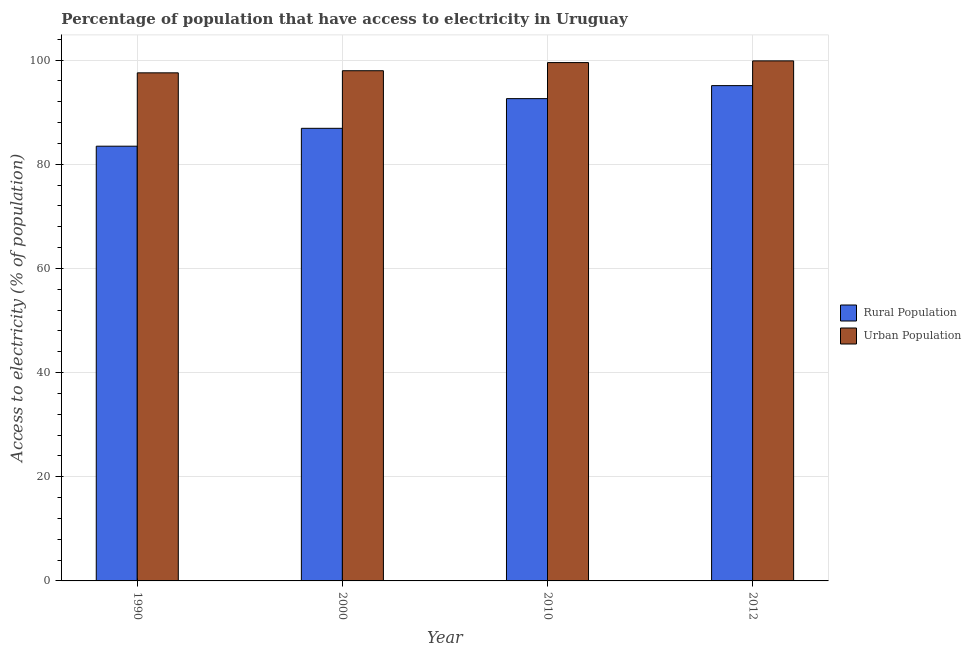Are the number of bars per tick equal to the number of legend labels?
Offer a terse response. Yes. Are the number of bars on each tick of the X-axis equal?
Give a very brief answer. Yes. What is the percentage of rural population having access to electricity in 2000?
Give a very brief answer. 86.9. Across all years, what is the maximum percentage of rural population having access to electricity?
Ensure brevity in your answer.  95.1. Across all years, what is the minimum percentage of rural population having access to electricity?
Offer a terse response. 83.47. In which year was the percentage of urban population having access to electricity maximum?
Provide a short and direct response. 2012. What is the total percentage of urban population having access to electricity in the graph?
Ensure brevity in your answer.  394.88. What is the difference between the percentage of urban population having access to electricity in 2010 and that in 2012?
Offer a terse response. -0.33. What is the difference between the percentage of urban population having access to electricity in 2012 and the percentage of rural population having access to electricity in 2010?
Ensure brevity in your answer.  0.33. What is the average percentage of urban population having access to electricity per year?
Your answer should be compact. 98.72. What is the ratio of the percentage of rural population having access to electricity in 2000 to that in 2010?
Offer a terse response. 0.94. Is the difference between the percentage of urban population having access to electricity in 2000 and 2010 greater than the difference between the percentage of rural population having access to electricity in 2000 and 2010?
Give a very brief answer. No. What is the difference between the highest and the second highest percentage of rural population having access to electricity?
Give a very brief answer. 2.5. What is the difference between the highest and the lowest percentage of urban population having access to electricity?
Keep it short and to the point. 2.3. What does the 1st bar from the left in 2012 represents?
Keep it short and to the point. Rural Population. What does the 2nd bar from the right in 2012 represents?
Keep it short and to the point. Rural Population. How many years are there in the graph?
Ensure brevity in your answer.  4. What is the difference between two consecutive major ticks on the Y-axis?
Provide a succinct answer. 20. Are the values on the major ticks of Y-axis written in scientific E-notation?
Provide a short and direct response. No. Does the graph contain any zero values?
Offer a very short reply. No. How many legend labels are there?
Offer a very short reply. 2. What is the title of the graph?
Offer a very short reply. Percentage of population that have access to electricity in Uruguay. Does "2012 US$" appear as one of the legend labels in the graph?
Provide a succinct answer. No. What is the label or title of the X-axis?
Your answer should be compact. Year. What is the label or title of the Y-axis?
Your answer should be very brief. Access to electricity (% of population). What is the Access to electricity (% of population) of Rural Population in 1990?
Provide a succinct answer. 83.47. What is the Access to electricity (% of population) in Urban Population in 1990?
Offer a very short reply. 97.55. What is the Access to electricity (% of population) in Rural Population in 2000?
Provide a succinct answer. 86.9. What is the Access to electricity (% of population) of Urban Population in 2000?
Keep it short and to the point. 97.96. What is the Access to electricity (% of population) of Rural Population in 2010?
Offer a very short reply. 92.6. What is the Access to electricity (% of population) of Urban Population in 2010?
Ensure brevity in your answer.  99.52. What is the Access to electricity (% of population) of Rural Population in 2012?
Offer a very short reply. 95.1. What is the Access to electricity (% of population) in Urban Population in 2012?
Your answer should be compact. 99.85. Across all years, what is the maximum Access to electricity (% of population) in Rural Population?
Your response must be concise. 95.1. Across all years, what is the maximum Access to electricity (% of population) of Urban Population?
Your answer should be very brief. 99.85. Across all years, what is the minimum Access to electricity (% of population) of Rural Population?
Make the answer very short. 83.47. Across all years, what is the minimum Access to electricity (% of population) in Urban Population?
Ensure brevity in your answer.  97.55. What is the total Access to electricity (% of population) of Rural Population in the graph?
Keep it short and to the point. 358.07. What is the total Access to electricity (% of population) of Urban Population in the graph?
Provide a short and direct response. 394.88. What is the difference between the Access to electricity (% of population) of Rural Population in 1990 and that in 2000?
Keep it short and to the point. -3.43. What is the difference between the Access to electricity (% of population) of Urban Population in 1990 and that in 2000?
Ensure brevity in your answer.  -0.41. What is the difference between the Access to electricity (% of population) in Rural Population in 1990 and that in 2010?
Make the answer very short. -9.13. What is the difference between the Access to electricity (% of population) in Urban Population in 1990 and that in 2010?
Keep it short and to the point. -1.97. What is the difference between the Access to electricity (% of population) in Rural Population in 1990 and that in 2012?
Offer a very short reply. -11.63. What is the difference between the Access to electricity (% of population) of Urban Population in 1990 and that in 2012?
Provide a short and direct response. -2.3. What is the difference between the Access to electricity (% of population) of Urban Population in 2000 and that in 2010?
Give a very brief answer. -1.56. What is the difference between the Access to electricity (% of population) in Rural Population in 2000 and that in 2012?
Your response must be concise. -8.2. What is the difference between the Access to electricity (% of population) of Urban Population in 2000 and that in 2012?
Provide a short and direct response. -1.89. What is the difference between the Access to electricity (% of population) in Rural Population in 2010 and that in 2012?
Offer a terse response. -2.5. What is the difference between the Access to electricity (% of population) of Urban Population in 2010 and that in 2012?
Give a very brief answer. -0.33. What is the difference between the Access to electricity (% of population) of Rural Population in 1990 and the Access to electricity (% of population) of Urban Population in 2000?
Keep it short and to the point. -14.49. What is the difference between the Access to electricity (% of population) of Rural Population in 1990 and the Access to electricity (% of population) of Urban Population in 2010?
Provide a succinct answer. -16.05. What is the difference between the Access to electricity (% of population) in Rural Population in 1990 and the Access to electricity (% of population) in Urban Population in 2012?
Ensure brevity in your answer.  -16.38. What is the difference between the Access to electricity (% of population) in Rural Population in 2000 and the Access to electricity (% of population) in Urban Population in 2010?
Your answer should be compact. -12.62. What is the difference between the Access to electricity (% of population) of Rural Population in 2000 and the Access to electricity (% of population) of Urban Population in 2012?
Give a very brief answer. -12.95. What is the difference between the Access to electricity (% of population) of Rural Population in 2010 and the Access to electricity (% of population) of Urban Population in 2012?
Provide a succinct answer. -7.25. What is the average Access to electricity (% of population) of Rural Population per year?
Your answer should be compact. 89.52. What is the average Access to electricity (% of population) of Urban Population per year?
Give a very brief answer. 98.72. In the year 1990, what is the difference between the Access to electricity (% of population) of Rural Population and Access to electricity (% of population) of Urban Population?
Your response must be concise. -14.08. In the year 2000, what is the difference between the Access to electricity (% of population) in Rural Population and Access to electricity (% of population) in Urban Population?
Provide a short and direct response. -11.06. In the year 2010, what is the difference between the Access to electricity (% of population) of Rural Population and Access to electricity (% of population) of Urban Population?
Make the answer very short. -6.92. In the year 2012, what is the difference between the Access to electricity (% of population) of Rural Population and Access to electricity (% of population) of Urban Population?
Your answer should be compact. -4.75. What is the ratio of the Access to electricity (% of population) of Rural Population in 1990 to that in 2000?
Provide a succinct answer. 0.96. What is the ratio of the Access to electricity (% of population) of Urban Population in 1990 to that in 2000?
Make the answer very short. 1. What is the ratio of the Access to electricity (% of population) in Rural Population in 1990 to that in 2010?
Make the answer very short. 0.9. What is the ratio of the Access to electricity (% of population) in Urban Population in 1990 to that in 2010?
Give a very brief answer. 0.98. What is the ratio of the Access to electricity (% of population) in Rural Population in 1990 to that in 2012?
Your response must be concise. 0.88. What is the ratio of the Access to electricity (% of population) of Rural Population in 2000 to that in 2010?
Your answer should be compact. 0.94. What is the ratio of the Access to electricity (% of population) of Urban Population in 2000 to that in 2010?
Offer a very short reply. 0.98. What is the ratio of the Access to electricity (% of population) of Rural Population in 2000 to that in 2012?
Make the answer very short. 0.91. What is the ratio of the Access to electricity (% of population) of Urban Population in 2000 to that in 2012?
Offer a very short reply. 0.98. What is the ratio of the Access to electricity (% of population) in Rural Population in 2010 to that in 2012?
Make the answer very short. 0.97. What is the ratio of the Access to electricity (% of population) of Urban Population in 2010 to that in 2012?
Your answer should be compact. 1. What is the difference between the highest and the second highest Access to electricity (% of population) of Urban Population?
Make the answer very short. 0.33. What is the difference between the highest and the lowest Access to electricity (% of population) in Rural Population?
Give a very brief answer. 11.63. What is the difference between the highest and the lowest Access to electricity (% of population) in Urban Population?
Keep it short and to the point. 2.3. 